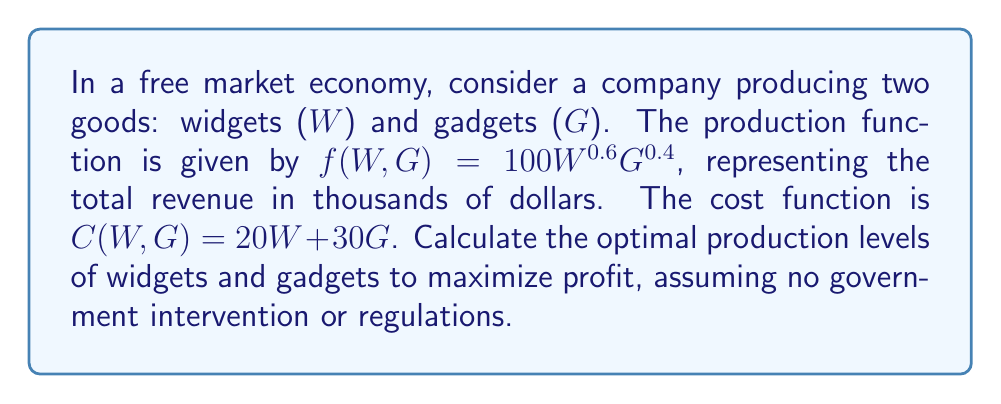What is the answer to this math problem? To find the optimal production levels, we need to maximize the profit function:

1. Define the profit function:
   $P(W,G) = f(W,G) - C(W,G) = 100W^{0.6}G^{0.4} - 20W - 30G$

2. Calculate partial derivatives with respect to W and G:
   $\frac{\partial P}{\partial W} = 60W^{-0.4}G^{0.4} - 20$
   $\frac{\partial P}{\partial G} = 40W^{0.6}G^{-0.6} - 30$

3. Set both partial derivatives to zero:
   $60W^{-0.4}G^{0.4} - 20 = 0$
   $40W^{0.6}G^{-0.6} - 30 = 0$

4. Solve the system of equations:
   From the first equation: $60W^{-0.4}G^{0.4} = 20$
   From the second equation: $40W^{0.6}G^{-0.6} = 30$

   Divide the first equation by the second:
   $\frac{60W^{-0.4}G^{0.4}}{40W^{0.6}G^{-0.6}} = \frac{20}{30}$

   Simplify: $\frac{3W^{-1}G}{2} = \frac{2}{3}$

   $G = \frac{4W}{9}$

5. Substitute this relation back into one of the original equations:
   $60W^{-0.4}(\frac{4W}{9})^{0.4} - 20 = 0$

   Simplify and solve for W:
   $W \approx 216$

6. Calculate G:
   $G \approx \frac{4(216)}{9} \approx 96$

Therefore, the optimal production levels are approximately 216 widgets and 96 gadgets.
Answer: $(W, G) \approx (216, 96)$ 